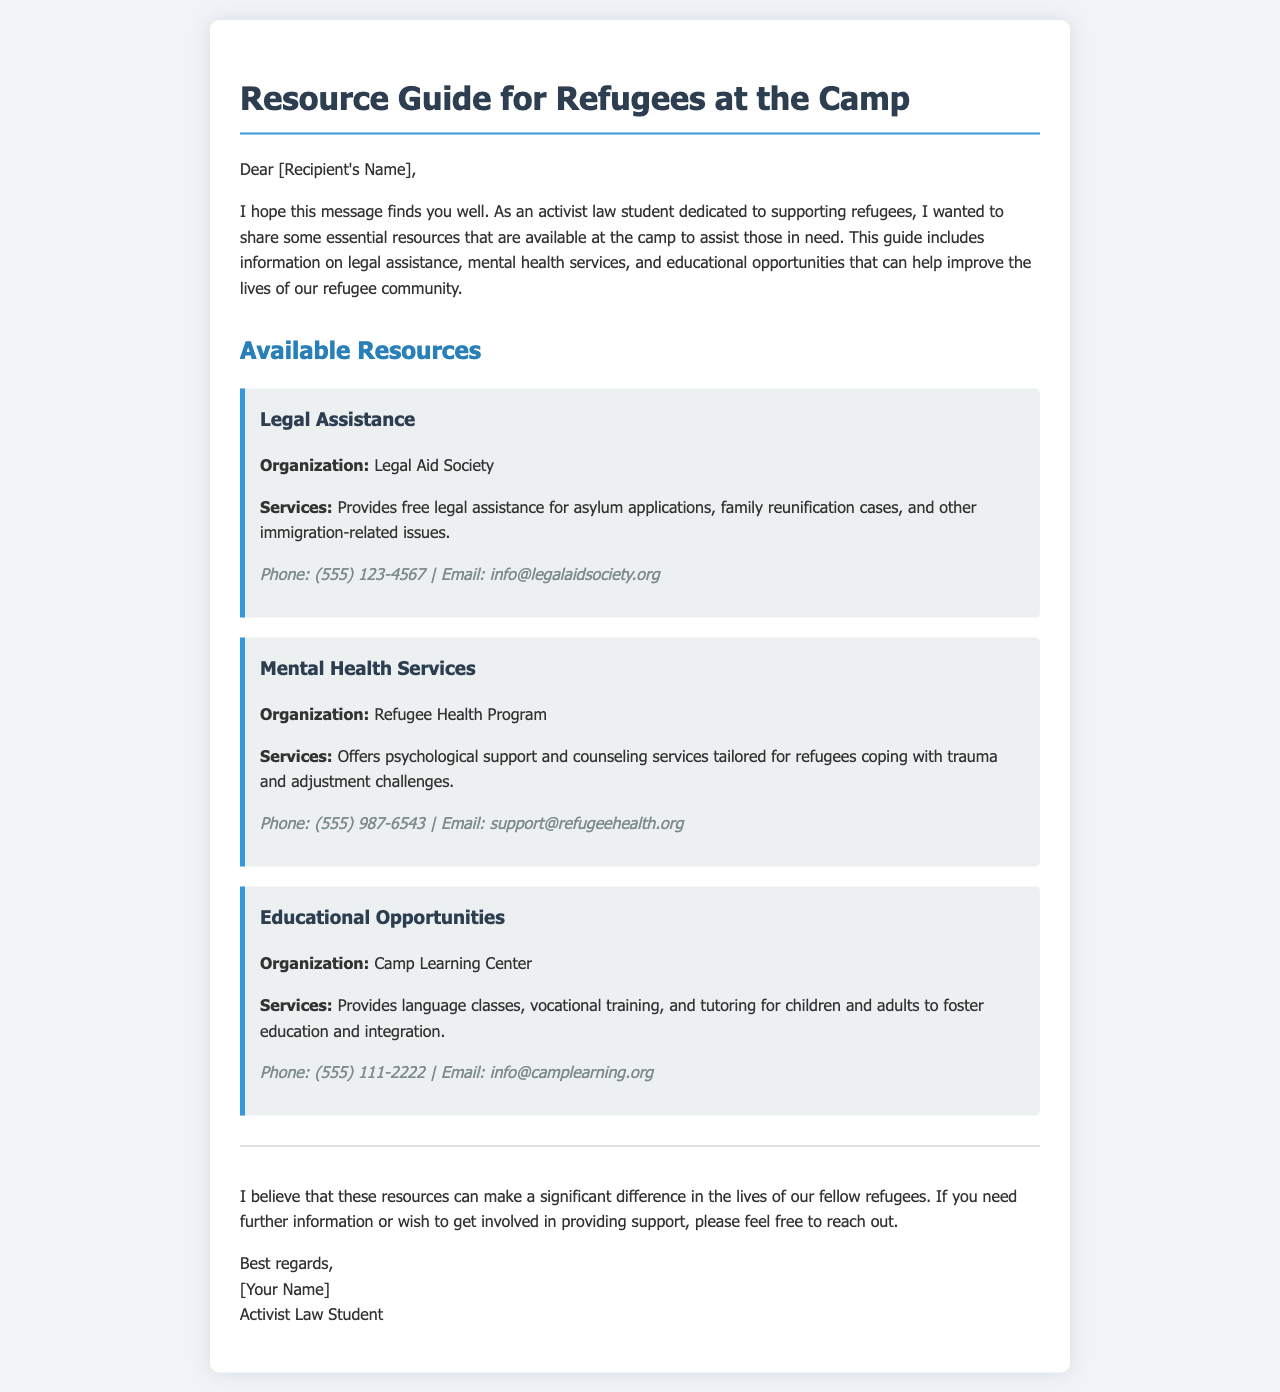What organization provides legal assistance? The document states that the Legal Aid Society provides legal assistance.
Answer: Legal Aid Society What services does the Refugee Health Program offer? According to the document, the Refugee Health Program offers psychological support and counseling services.
Answer: Psychological support and counseling services What is the contact email for the Camp Learning Center? The document provides the email address for the Camp Learning Center, which is info@camplearning.org.
Answer: info@camplearning.org How many types of resources are mentioned in the document? The document mentions three types of resources: legal assistance, mental health services, and educational opportunities.
Answer: Three What is the purpose of the Resource Guide? The document indicates that the purpose is to share essential resources to assist refugees in need.
Answer: Assist refugees in need What phone number can be used to contact the Legal Aid Society? The document lists the phone number for the Legal Aid Society as (555) 123-4567.
Answer: (555) 123-4567 What type of classes are offered at the Camp Learning Center? The document mentions that the Camp Learning Center provides language classes.
Answer: Language classes Who is the author of the document? The document is authored by an activist law student, as stated at the end.
Answer: Activist Law Student 